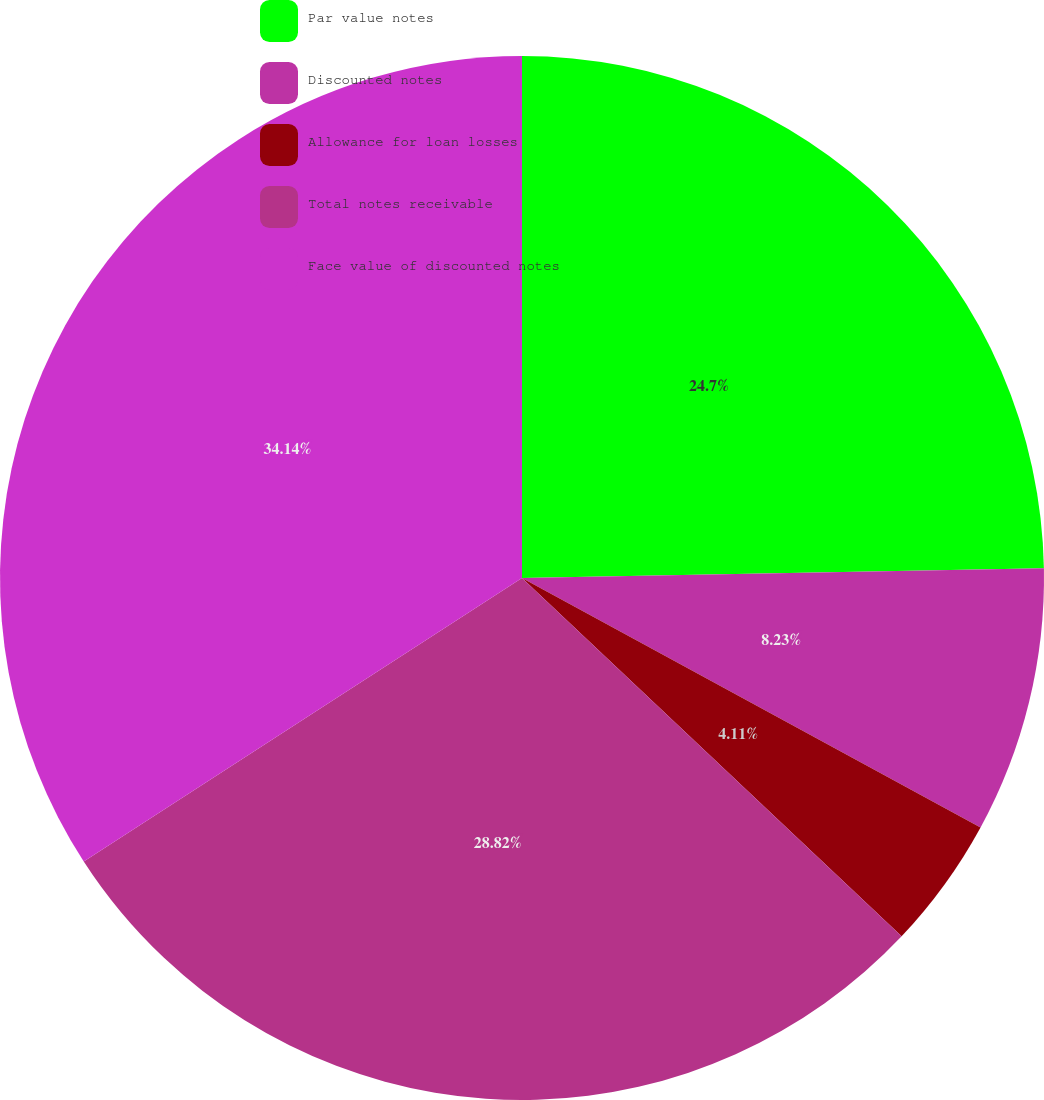Convert chart to OTSL. <chart><loc_0><loc_0><loc_500><loc_500><pie_chart><fcel>Par value notes<fcel>Discounted notes<fcel>Allowance for loan losses<fcel>Total notes receivable<fcel>Face value of discounted notes<nl><fcel>24.7%<fcel>8.23%<fcel>4.11%<fcel>28.82%<fcel>34.14%<nl></chart> 